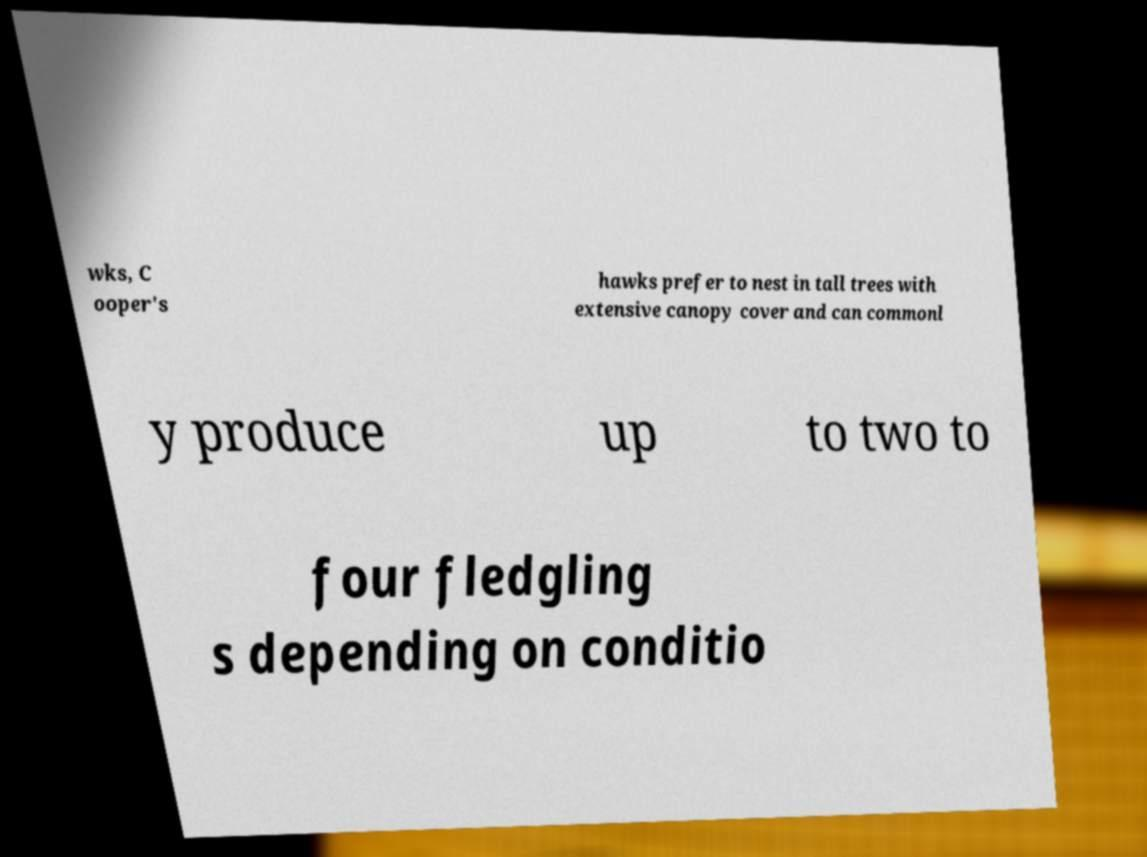Please read and relay the text visible in this image. What does it say? wks, C ooper's hawks prefer to nest in tall trees with extensive canopy cover and can commonl y produce up to two to four fledgling s depending on conditio 